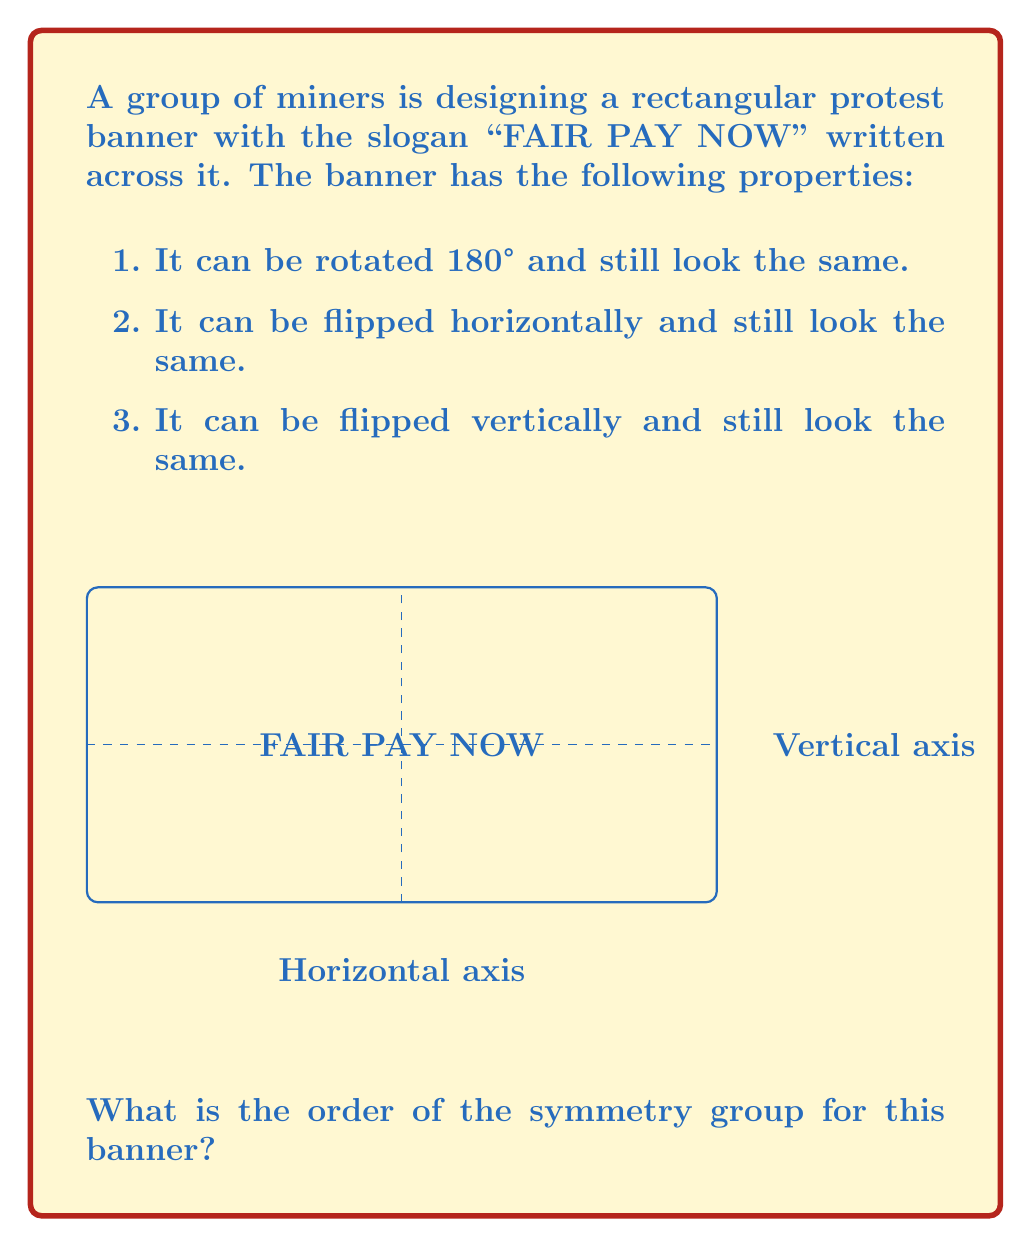Can you answer this question? Let's approach this step-by-step:

1) First, we need to identify all the symmetry operations that leave the banner unchanged:

   a) Identity (E): Leaving the banner as it is.
   b) Rotation by 180° (R): Rotating the banner 180°.
   c) Horizontal flip (H): Flipping the banner horizontally.
   d) Vertical flip (V): Flipping the banner vertically.

2) These operations form a group because:
   - They are closed (performing any two operations results in one of these operations).
   - They have an identity element (E).
   - Each operation has an inverse (each operation is its own inverse).
   - They are associative.

3) To find the order of the group, we need to count the number of distinct elements:
   $|G| = |\{E, R, H, V\}| = 4$

4) We can verify this is correct by creating a group table:

   $$ \begin{array}{c|cccc}
      & E & R & H & V \\
      \hline
      E & E & R & H & V \\
      R & R & E & V & H \\
      H & H & V & E & R \\
      V & V & H & R & E
   \end{array} $$

5) This group is isomorphic to the Klein four-group ($V_4$ or $C_2 \times C_2$).

Therefore, the order of the symmetry group for this banner is 4.
Answer: 4 